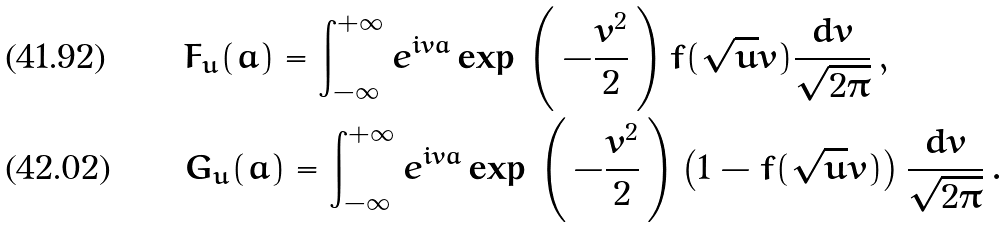Convert formula to latex. <formula><loc_0><loc_0><loc_500><loc_500>& F _ { u } ( a ) = \int _ { - \infty } ^ { + \infty } e ^ { i v a } \exp \, \left ( \, - \frac { v ^ { 2 } } { 2 } \, \right ) f ( \sqrt { u } v ) \frac { d v } { \sqrt { 2 \pi } } \, , \\ & G _ { u } ( a ) = \int _ { - \infty } ^ { + \infty } e ^ { i v a } \exp \, \left ( \, - \frac { v ^ { 2 } } { 2 } \, \right ) \left ( 1 - f ( \sqrt { u } v ) \right ) \frac { d v } { \sqrt { 2 \pi } } \, .</formula> 